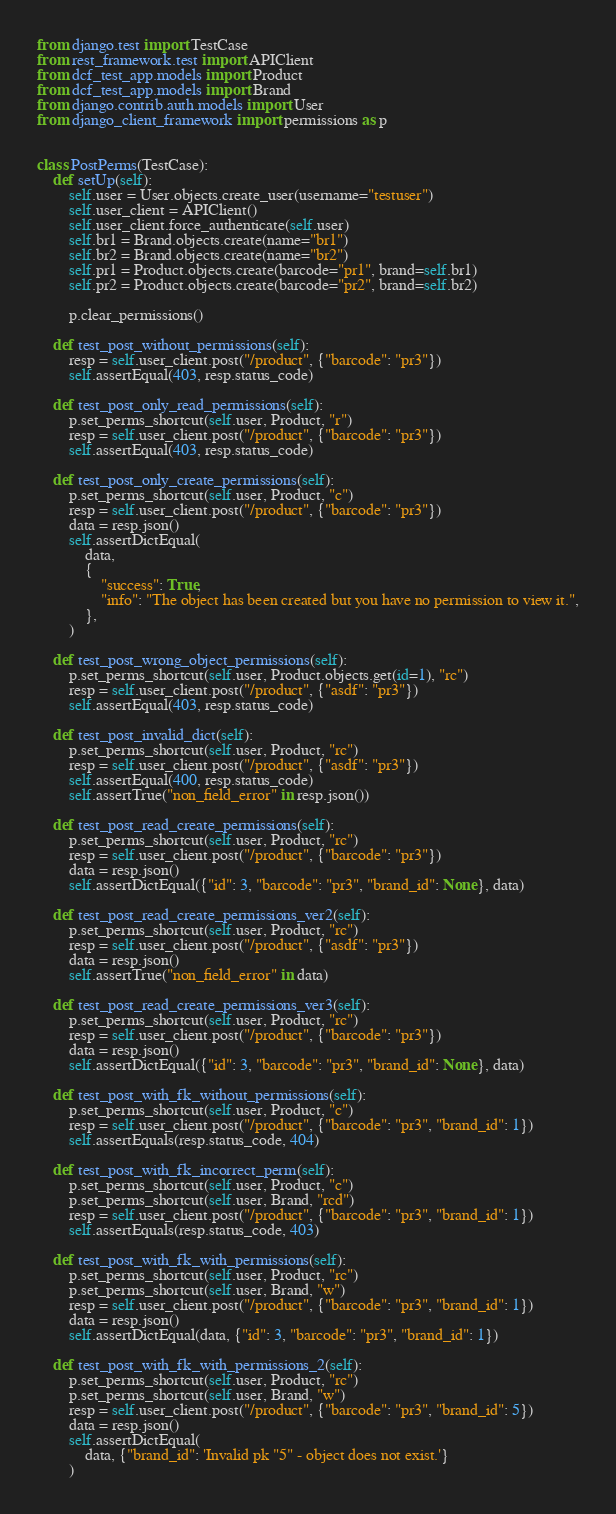<code> <loc_0><loc_0><loc_500><loc_500><_Python_>from django.test import TestCase
from rest_framework.test import APIClient
from dcf_test_app.models import Product
from dcf_test_app.models import Brand
from django.contrib.auth.models import User
from django_client_framework import permissions as p


class PostPerms(TestCase):
    def setUp(self):
        self.user = User.objects.create_user(username="testuser")
        self.user_client = APIClient()
        self.user_client.force_authenticate(self.user)
        self.br1 = Brand.objects.create(name="br1")
        self.br2 = Brand.objects.create(name="br2")
        self.pr1 = Product.objects.create(barcode="pr1", brand=self.br1)
        self.pr2 = Product.objects.create(barcode="pr2", brand=self.br2)

        p.clear_permissions()

    def test_post_without_permissions(self):
        resp = self.user_client.post("/product", {"barcode": "pr3"})
        self.assertEqual(403, resp.status_code)

    def test_post_only_read_permissions(self):
        p.set_perms_shortcut(self.user, Product, "r")
        resp = self.user_client.post("/product", {"barcode": "pr3"})
        self.assertEqual(403, resp.status_code)

    def test_post_only_create_permissions(self):
        p.set_perms_shortcut(self.user, Product, "c")
        resp = self.user_client.post("/product", {"barcode": "pr3"})
        data = resp.json()
        self.assertDictEqual(
            data,
            {
                "success": True,
                "info": "The object has been created but you have no permission to view it.",
            },
        )

    def test_post_wrong_object_permissions(self):
        p.set_perms_shortcut(self.user, Product.objects.get(id=1), "rc")
        resp = self.user_client.post("/product", {"asdf": "pr3"})
        self.assertEqual(403, resp.status_code)

    def test_post_invalid_dict(self):
        p.set_perms_shortcut(self.user, Product, "rc")
        resp = self.user_client.post("/product", {"asdf": "pr3"})
        self.assertEqual(400, resp.status_code)
        self.assertTrue("non_field_error" in resp.json())

    def test_post_read_create_permissions(self):
        p.set_perms_shortcut(self.user, Product, "rc")
        resp = self.user_client.post("/product", {"barcode": "pr3"})
        data = resp.json()
        self.assertDictEqual({"id": 3, "barcode": "pr3", "brand_id": None}, data)

    def test_post_read_create_permissions_ver2(self):
        p.set_perms_shortcut(self.user, Product, "rc")
        resp = self.user_client.post("/product", {"asdf": "pr3"})
        data = resp.json()
        self.assertTrue("non_field_error" in data)

    def test_post_read_create_permissions_ver3(self):
        p.set_perms_shortcut(self.user, Product, "rc")
        resp = self.user_client.post("/product", {"barcode": "pr3"})
        data = resp.json()
        self.assertDictEqual({"id": 3, "barcode": "pr3", "brand_id": None}, data)

    def test_post_with_fk_without_permissions(self):
        p.set_perms_shortcut(self.user, Product, "c")
        resp = self.user_client.post("/product", {"barcode": "pr3", "brand_id": 1})
        self.assertEquals(resp.status_code, 404)

    def test_post_with_fk_incorrect_perm(self):
        p.set_perms_shortcut(self.user, Product, "c")
        p.set_perms_shortcut(self.user, Brand, "rcd")
        resp = self.user_client.post("/product", {"barcode": "pr3", "brand_id": 1})
        self.assertEquals(resp.status_code, 403)

    def test_post_with_fk_with_permissions(self):
        p.set_perms_shortcut(self.user, Product, "rc")
        p.set_perms_shortcut(self.user, Brand, "w")
        resp = self.user_client.post("/product", {"barcode": "pr3", "brand_id": 1})
        data = resp.json()
        self.assertDictEqual(data, {"id": 3, "barcode": "pr3", "brand_id": 1})

    def test_post_with_fk_with_permissions_2(self):
        p.set_perms_shortcut(self.user, Product, "rc")
        p.set_perms_shortcut(self.user, Brand, "w")
        resp = self.user_client.post("/product", {"barcode": "pr3", "brand_id": 5})
        data = resp.json()
        self.assertDictEqual(
            data, {"brand_id": 'Invalid pk "5" - object does not exist.'}
        )
</code> 